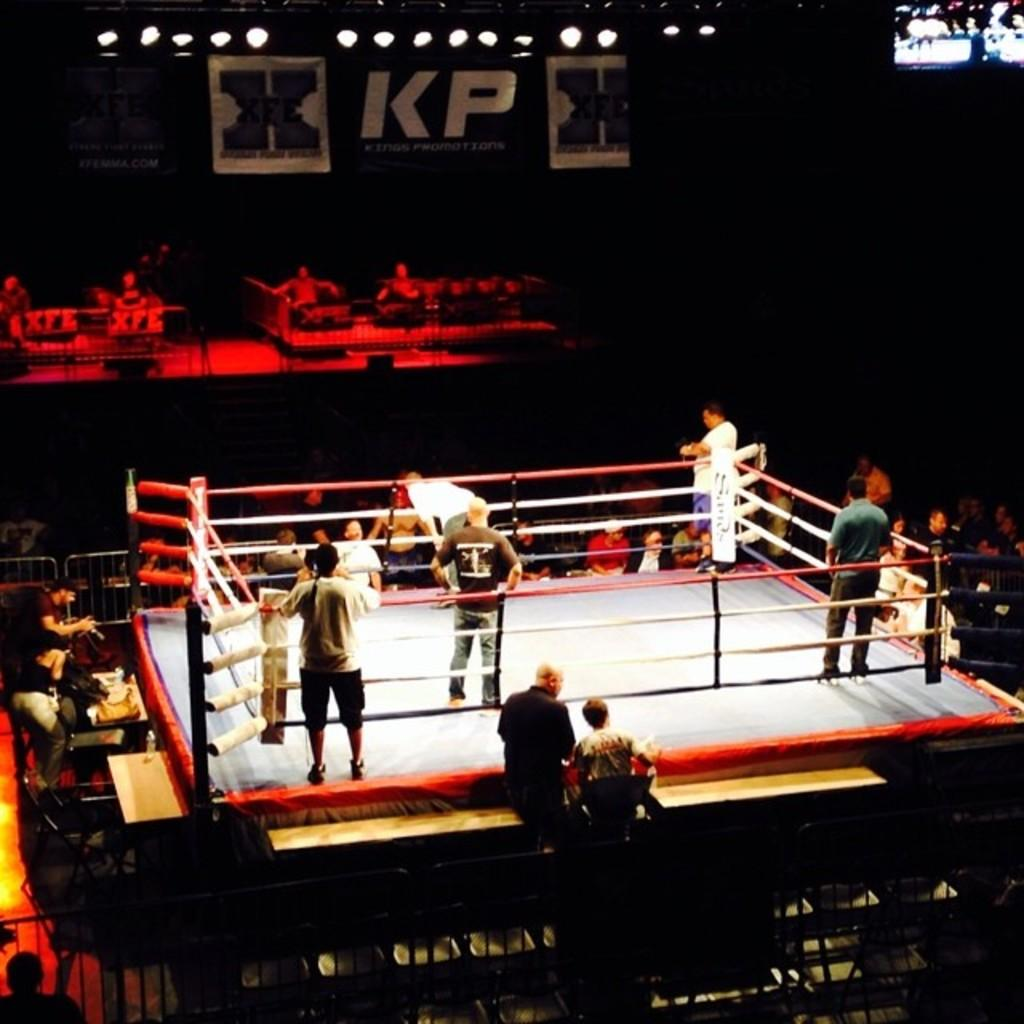<image>
Write a terse but informative summary of the picture. People standing in the ring of a KP Promotions boxing event. 